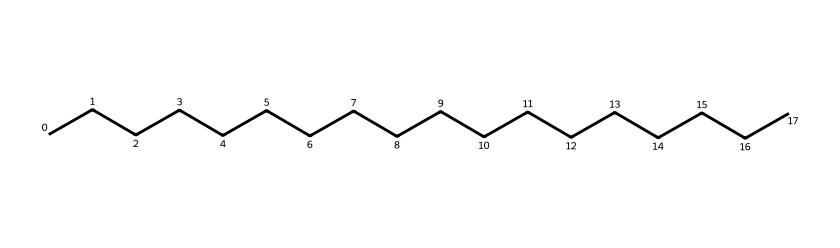What is the main type of structure seen in this chemical? The structure shows a long carbon chain with hydrogen atoms attached, which indicates that it is a hydrocarbon. The presence of only carbon and hydrogen means that it is a saturated alkane.
Answer: hydrocarbon How many carbon atoms are present in this chemical? By looking at the SMILES representation, "CCCCCCCCCCCCCCCCCC," it shows 18 consecutive 'C' characters, indicating there are 18 carbon atoms.
Answer: 18 Does this lubricant have any unsaturation? The structure consists only of single bonds between carbon atoms, indicating it is a saturated compound; hence there is no unsaturation present.
Answer: no What is the expected state of this lubricant at room temperature? Given that it is a long-chain hydrocarbon (alkane) and considering the general properties of such compounds, it is likely to be a liquid or semi-solid at room temperature, with possible variations depending on specific conditions.
Answer: liquid What is the likely boiling point range of this compound? Long-chain alkanes typically have higher boiling points due to stronger van der Waals forces. Considering this is an 18-carbon chain, the boiling point is likely between 250-300 degrees Celsius.
Answer: 250-300 degrees Celsius What functional properties does this lubricant provide due to its structure? The long hydrocarbon chain provides excellent lubricating properties due to lower viscosity and high film strength, reducing friction between mechanical parts.
Answer: excellent lubrication 